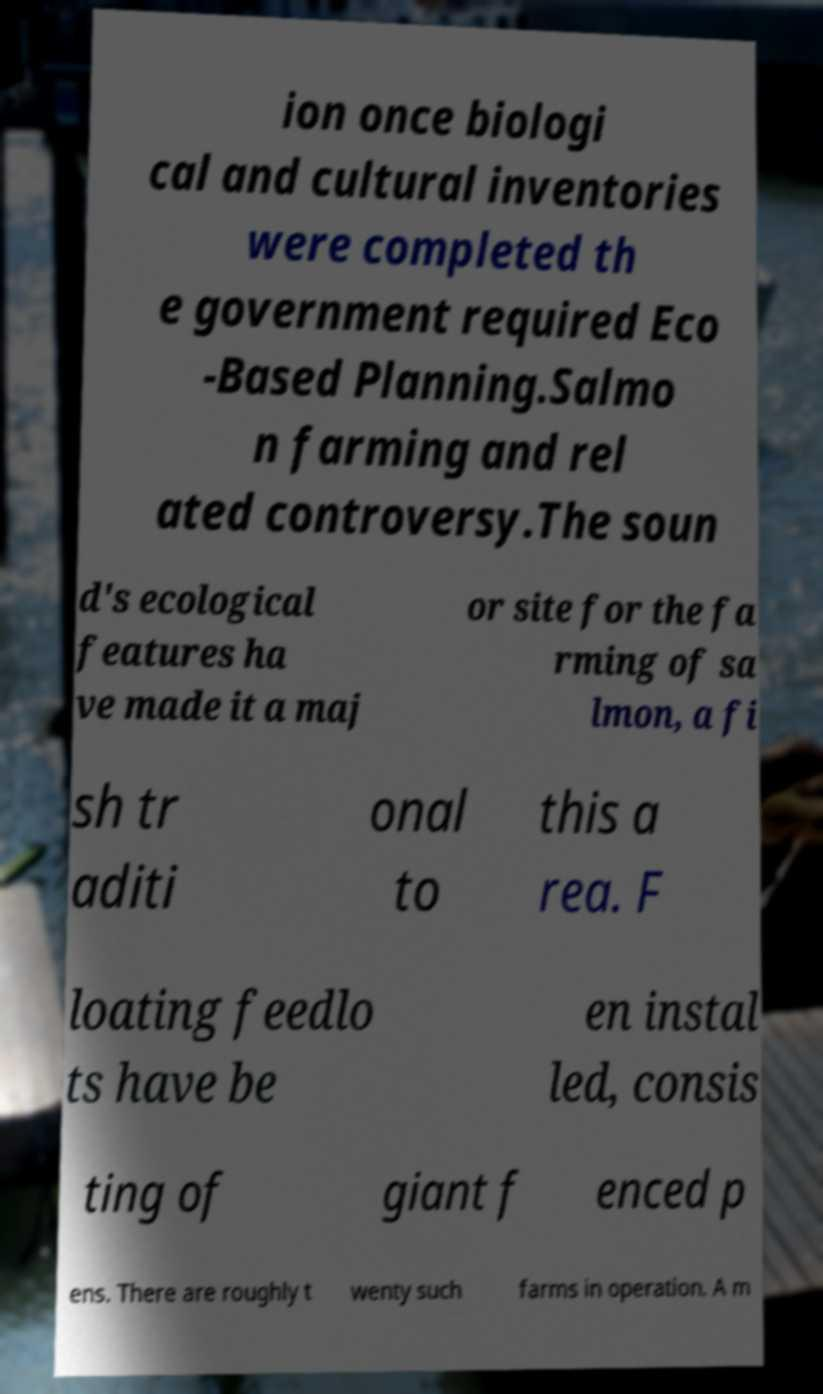Please read and relay the text visible in this image. What does it say? ion once biologi cal and cultural inventories were completed th e government required Eco -Based Planning.Salmo n farming and rel ated controversy.The soun d's ecological features ha ve made it a maj or site for the fa rming of sa lmon, a fi sh tr aditi onal to this a rea. F loating feedlo ts have be en instal led, consis ting of giant f enced p ens. There are roughly t wenty such farms in operation. A m 